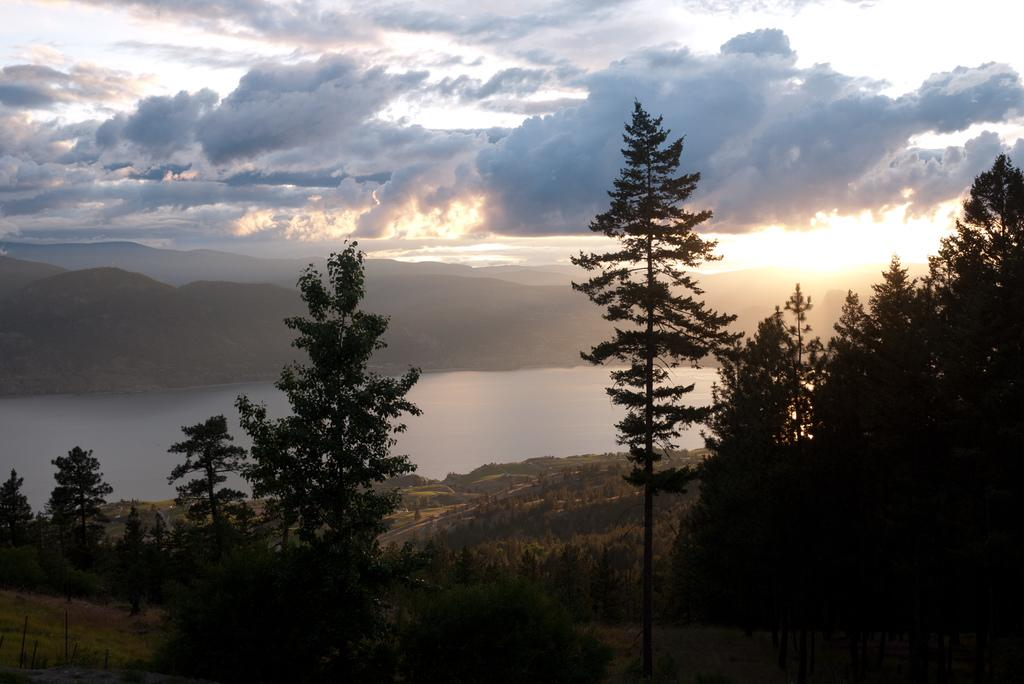What type of natural environment is depicted in the image? The image features trees, a lake, and mountains in the background. What can be seen in the sky in the image? The sky is visible in the background of the image. What type of horses are depicted in the image? There are no horses present in the image. 